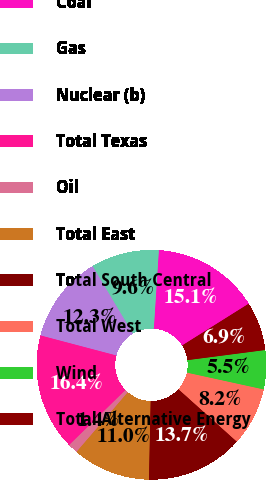Convert chart to OTSL. <chart><loc_0><loc_0><loc_500><loc_500><pie_chart><fcel>Coal<fcel>Gas<fcel>Nuclear (b)<fcel>Total Texas<fcel>Oil<fcel>Total East<fcel>Total South Central<fcel>Total West<fcel>Wind<fcel>Total Alternative Energy<nl><fcel>15.06%<fcel>9.59%<fcel>12.32%<fcel>16.42%<fcel>1.39%<fcel>10.96%<fcel>13.69%<fcel>8.22%<fcel>5.49%<fcel>6.86%<nl></chart> 